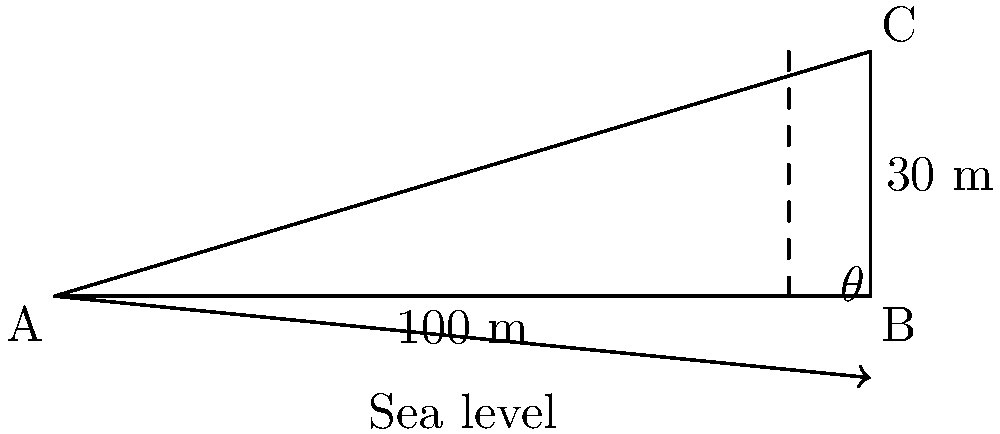The White Cliffs of Dover are an iconic symbol of Britain's coastline and have played a significant role in European history. As a professor studying the geographical context of Brexit, you're analyzing the cliffs' physical characteristics. From a boat 100 meters from the base of the cliffs, you measure the height to be 30 meters. Calculate the angle of inclination ($\theta$) of the White Cliffs of Dover to the nearest degree. To solve this problem, we'll use the tangent trigonometric ratio. Let's approach this step-by-step:

1) In the right-angled triangle formed by the cliff, we have:
   - The adjacent side (distance from the boat to the base) = 100 m
   - The opposite side (height of the cliff) = 30 m
   - We need to find the angle $\theta$

2) The tangent of an angle in a right-angled triangle is defined as:

   $\tan(\theta) = \frac{\text{opposite}}{\text{adjacent}}$

3) Substituting our values:

   $\tan(\theta) = \frac{30}{100} = 0.3$

4) To find $\theta$, we need to use the inverse tangent (arctangent) function:

   $\theta = \tan^{-1}(0.3)$

5) Using a calculator or trigonometric tables:

   $\theta \approx 16.70^\circ$

6) Rounding to the nearest degree:

   $\theta \approx 17^\circ$

This angle represents the inclination of the White Cliffs of Dover, providing a quantitative measure of the landscape that has been so crucial in British and European history, from ancient times through World War II and now in the context of Brexit.
Answer: $17^\circ$ 